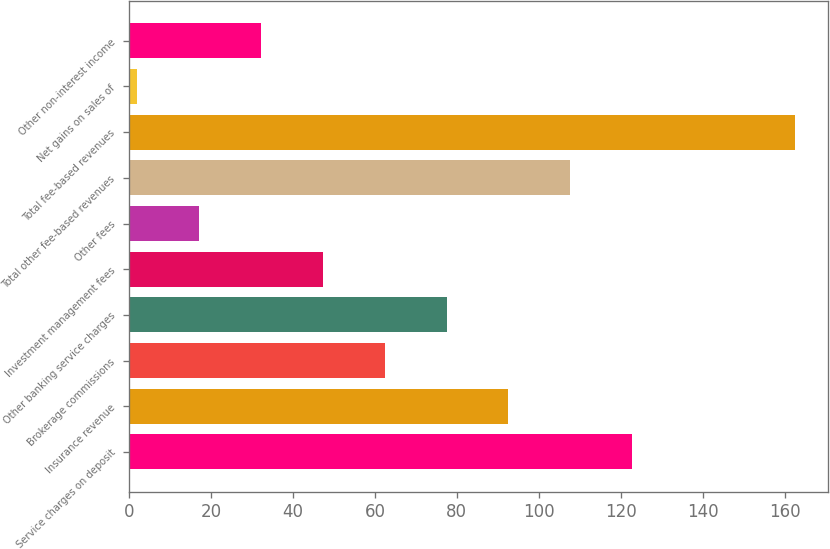Convert chart. <chart><loc_0><loc_0><loc_500><loc_500><bar_chart><fcel>Service charges on deposit<fcel>Insurance revenue<fcel>Brokerage commissions<fcel>Other banking service charges<fcel>Investment management fees<fcel>Other fees<fcel>Total other fee-based revenues<fcel>Total fee-based revenues<fcel>Net gains on sales of<fcel>Other non-interest income<nl><fcel>122.8<fcel>92.6<fcel>62.4<fcel>77.5<fcel>47.3<fcel>17.1<fcel>107.7<fcel>162.5<fcel>2<fcel>32.2<nl></chart> 